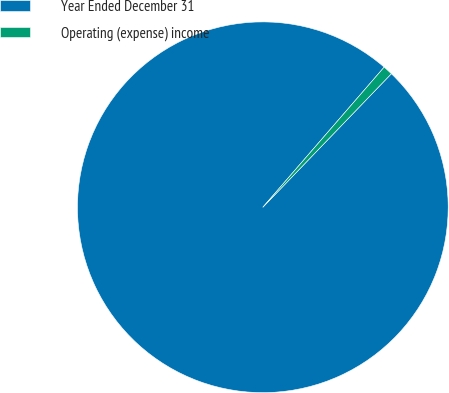Convert chart to OTSL. <chart><loc_0><loc_0><loc_500><loc_500><pie_chart><fcel>Year Ended December 31<fcel>Operating (expense) income<nl><fcel>99.16%<fcel>0.84%<nl></chart> 